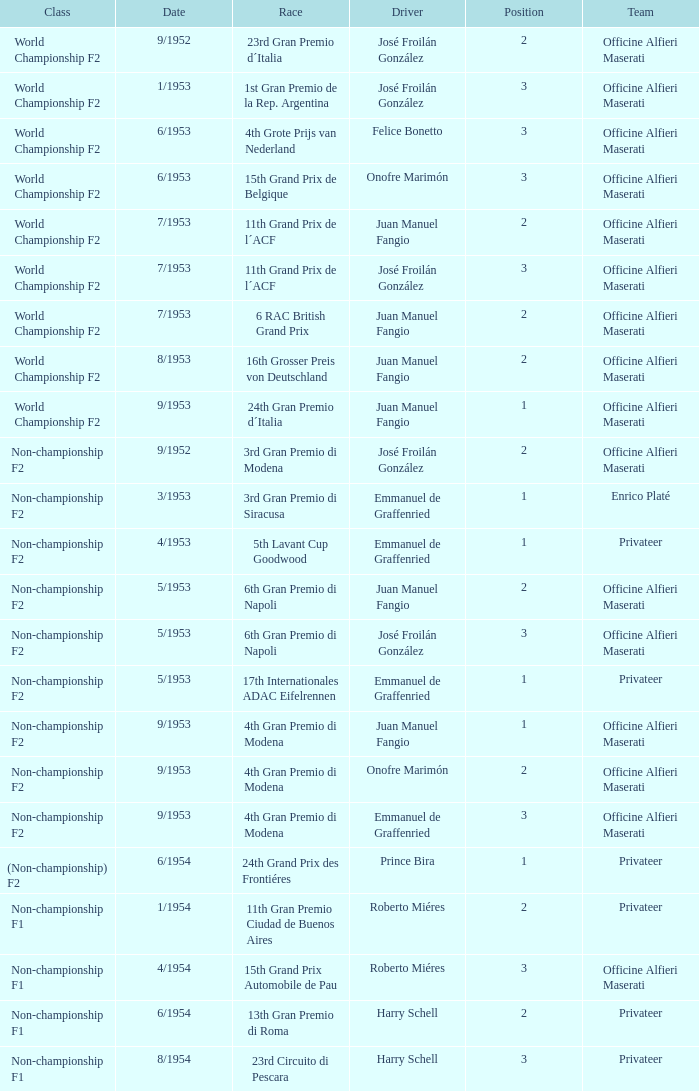When is the class of non-championship f2 featuring a driver named josé froilán gonzález who holds a position exceeding 2? 5/1953. 